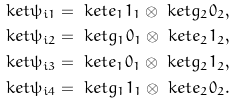<formula> <loc_0><loc_0><loc_500><loc_500>\ k e t { \psi _ { i 1 } } & = \ k e t { e _ { 1 } 1 _ { 1 } } \otimes \ k e t { g _ { 2 } 0 _ { 2 } } , \\ \ k e t { \psi _ { i 2 } } & = \ k e t { g _ { 1 } 0 _ { 1 } } \otimes \ k e t { e _ { 2 } 1 _ { 2 } } , \\ \ k e t { \psi _ { i 3 } } & = \ k e t { e _ { 1 } 0 _ { 1 } } \otimes \ k e t { g _ { 2 } 1 _ { 2 } } , \\ \ k e t { \psi _ { i 4 } } & = \ k e t { g _ { 1 } 1 _ { 1 } } \otimes \ k e t { e _ { 2 } 0 _ { 2 } } .</formula> 